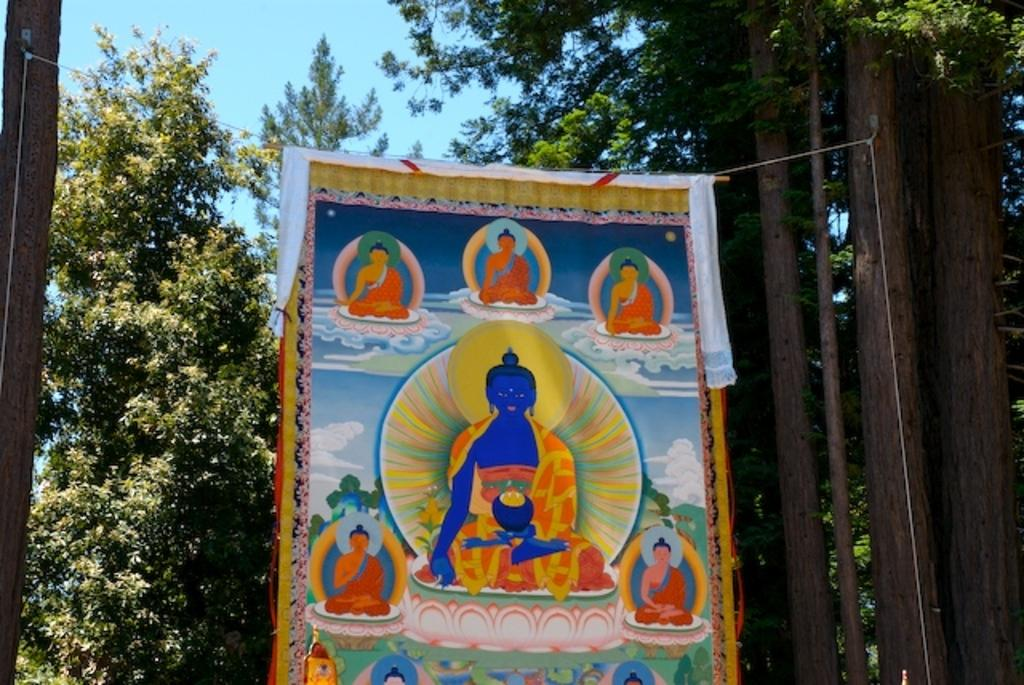What is located at the front of the image? There is a banner in the front of the image. What can be seen in the background of the image? There are trees in the background of the image. What is visible at the top of the image? The sky is visible at the top of the image. What is depicted on the banner? There are depictions on the banner. How many sisters are depicted on the banner? There are no sisters depicted on the banner; it only contains depictions mentioned in the facts. Can you hear someone coughing in the image? There is no auditory information provided in the image, so it is impossible to determine if someone is coughing. 